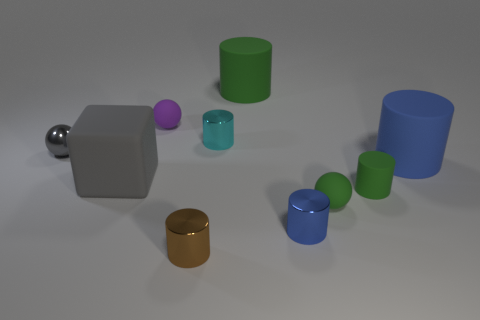How many big green spheres are there?
Your response must be concise. 0. The large rubber object that is in front of the blue cylinder that is to the right of the green matte cylinder on the right side of the small blue thing is what shape?
Provide a succinct answer. Cube. Are there fewer big gray things in front of the big blue rubber cylinder than big rubber cylinders that are in front of the small gray object?
Provide a short and direct response. No. There is a tiny brown thing in front of the rubber block; is its shape the same as the tiny rubber thing that is behind the tiny gray metallic sphere?
Your answer should be compact. No. What is the shape of the small shiny object that is behind the metal thing that is left of the large gray cube?
Provide a succinct answer. Cylinder. What size is the other rubber cylinder that is the same color as the small matte cylinder?
Provide a short and direct response. Large. Is there a tiny green cylinder made of the same material as the big blue object?
Your answer should be very brief. Yes. What material is the ball that is behind the small cyan metallic thing?
Your answer should be very brief. Rubber. What material is the purple object?
Provide a succinct answer. Rubber. Does the green cylinder that is in front of the gray shiny ball have the same material as the cyan cylinder?
Your response must be concise. No. 